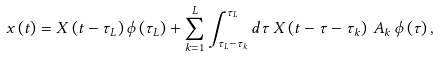Convert formula to latex. <formula><loc_0><loc_0><loc_500><loc_500>x \left ( t \right ) = X \left ( t - \tau _ { L } \right ) \phi \left ( \tau _ { L } \right ) + \sum _ { k = 1 } ^ { L } \int _ { \tau _ { L } - \tau _ { k } } ^ { \tau _ { L } } d \tau \, X \left ( t - \tau - \tau _ { k } \right ) \, A _ { k } \, \phi \left ( \tau \right ) ,</formula> 